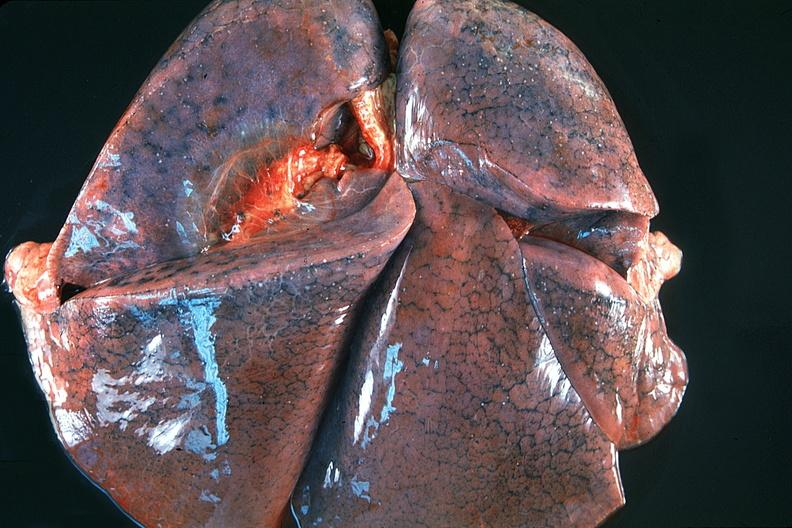where is this?
Answer the question using a single word or phrase. Lung 